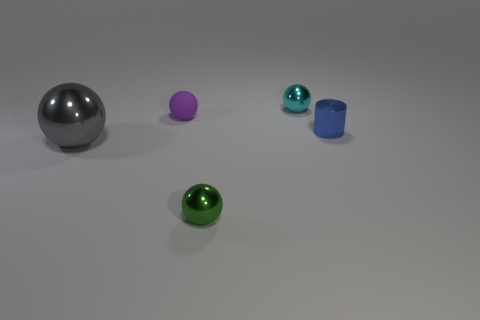Subtract all metal balls. How many balls are left? 1 Add 3 metallic cylinders. How many objects exist? 8 Subtract all gray balls. How many balls are left? 3 Subtract 1 cylinders. How many cylinders are left? 0 Add 4 large gray shiny balls. How many large gray shiny balls are left? 5 Add 2 big cyan blocks. How many big cyan blocks exist? 2 Subtract 0 red cylinders. How many objects are left? 5 Subtract all cylinders. How many objects are left? 4 Subtract all cyan cylinders. Subtract all green spheres. How many cylinders are left? 1 Subtract all gray blocks. How many cyan balls are left? 1 